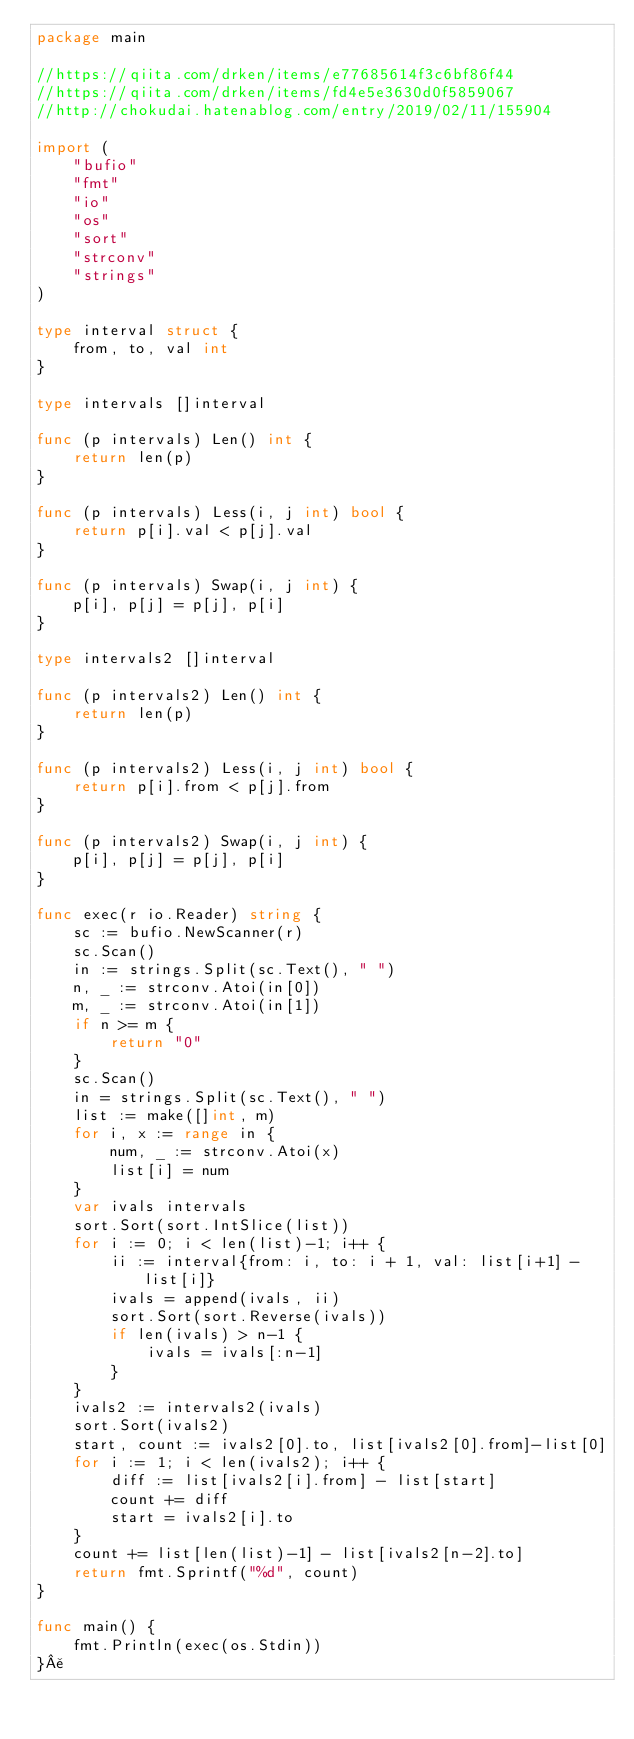<code> <loc_0><loc_0><loc_500><loc_500><_Go_>package main

//https://qiita.com/drken/items/e77685614f3c6bf86f44
//https://qiita.com/drken/items/fd4e5e3630d0f5859067
//http://chokudai.hatenablog.com/entry/2019/02/11/155904

import (
	"bufio"
	"fmt"
	"io"
	"os"
	"sort"
	"strconv"
	"strings"
)

type interval struct {
	from, to, val int
}

type intervals []interval

func (p intervals) Len() int {
	return len(p)
}

func (p intervals) Less(i, j int) bool {
	return p[i].val < p[j].val
}

func (p intervals) Swap(i, j int) {
	p[i], p[j] = p[j], p[i]
}

type intervals2 []interval

func (p intervals2) Len() int {
	return len(p)
}

func (p intervals2) Less(i, j int) bool {
	return p[i].from < p[j].from
}

func (p intervals2) Swap(i, j int) {
	p[i], p[j] = p[j], p[i]
}

func exec(r io.Reader) string {
	sc := bufio.NewScanner(r)
	sc.Scan()
	in := strings.Split(sc.Text(), " ")
	n, _ := strconv.Atoi(in[0])
	m, _ := strconv.Atoi(in[1])
	if n >= m {
		return "0"
	}
	sc.Scan()
	in = strings.Split(sc.Text(), " ")
	list := make([]int, m)
	for i, x := range in {
		num, _ := strconv.Atoi(x)
		list[i] = num
	}
	var ivals intervals
	sort.Sort(sort.IntSlice(list))
	for i := 0; i < len(list)-1; i++ {
		ii := interval{from: i, to: i + 1, val: list[i+1] - list[i]}
		ivals = append(ivals, ii)
		sort.Sort(sort.Reverse(ivals))
		if len(ivals) > n-1 {
			ivals = ivals[:n-1]
		}
	}
	ivals2 := intervals2(ivals)
	sort.Sort(ivals2)
	start, count := ivals2[0].to, list[ivals2[0].from]-list[0]
	for i := 1; i < len(ivals2); i++ {
		diff := list[ivals2[i].from] - list[start]
		count += diff
		start = ivals2[i].to
	}
	count += list[len(list)-1] - list[ivals2[n-2].to]
	return fmt.Sprintf("%d", count)
}

func main() {
	fmt.Println(exec(os.Stdin))
}¥</code> 